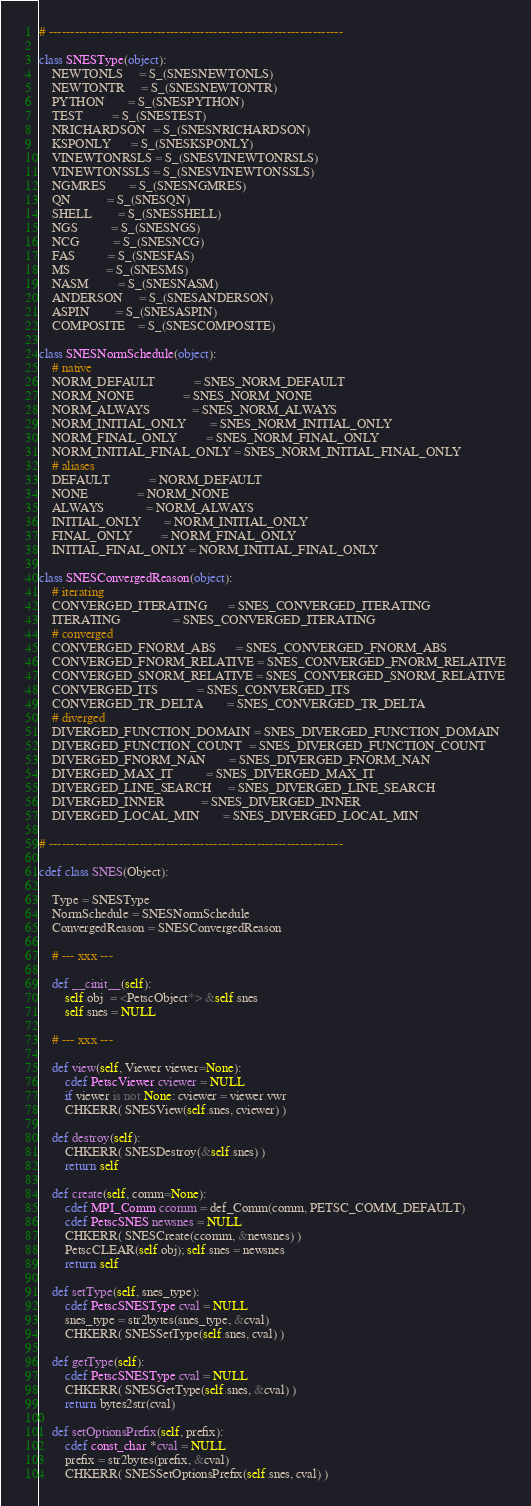Convert code to text. <code><loc_0><loc_0><loc_500><loc_500><_Cython_># --------------------------------------------------------------------

class SNESType(object):
    NEWTONLS     = S_(SNESNEWTONLS)
    NEWTONTR     = S_(SNESNEWTONTR)
    PYTHON       = S_(SNESPYTHON)
    TEST         = S_(SNESTEST)
    NRICHARDSON  = S_(SNESNRICHARDSON)
    KSPONLY      = S_(SNESKSPONLY)
    VINEWTONRSLS = S_(SNESVINEWTONRSLS)
    VINEWTONSSLS = S_(SNESVINEWTONSSLS)
    NGMRES       = S_(SNESNGMRES)
    QN           = S_(SNESQN)
    SHELL        = S_(SNESSHELL)
    NGS          = S_(SNESNGS)
    NCG          = S_(SNESNCG)
    FAS          = S_(SNESFAS)
    MS           = S_(SNESMS)
    NASM         = S_(SNESNASM)
    ANDERSON     = S_(SNESANDERSON)
    ASPIN        = S_(SNESASPIN)
    COMPOSITE    = S_(SNESCOMPOSITE)

class SNESNormSchedule(object):
    # native
    NORM_DEFAULT            = SNES_NORM_DEFAULT
    NORM_NONE               = SNES_NORM_NONE
    NORM_ALWAYS             = SNES_NORM_ALWAYS
    NORM_INITIAL_ONLY       = SNES_NORM_INITIAL_ONLY
    NORM_FINAL_ONLY         = SNES_NORM_FINAL_ONLY
    NORM_INITIAL_FINAL_ONLY = SNES_NORM_INITIAL_FINAL_ONLY
    # aliases
    DEFAULT            = NORM_DEFAULT
    NONE               = NORM_NONE
    ALWAYS             = NORM_ALWAYS
    INITIAL_ONLY       = NORM_INITIAL_ONLY
    FINAL_ONLY         = NORM_FINAL_ONLY
    INITIAL_FINAL_ONLY = NORM_INITIAL_FINAL_ONLY

class SNESConvergedReason(object):
    # iterating
    CONVERGED_ITERATING      = SNES_CONVERGED_ITERATING
    ITERATING                = SNES_CONVERGED_ITERATING
    # converged
    CONVERGED_FNORM_ABS      = SNES_CONVERGED_FNORM_ABS
    CONVERGED_FNORM_RELATIVE = SNES_CONVERGED_FNORM_RELATIVE
    CONVERGED_SNORM_RELATIVE = SNES_CONVERGED_SNORM_RELATIVE
    CONVERGED_ITS            = SNES_CONVERGED_ITS
    CONVERGED_TR_DELTA       = SNES_CONVERGED_TR_DELTA
    # diverged
    DIVERGED_FUNCTION_DOMAIN = SNES_DIVERGED_FUNCTION_DOMAIN
    DIVERGED_FUNCTION_COUNT  = SNES_DIVERGED_FUNCTION_COUNT
    DIVERGED_FNORM_NAN       = SNES_DIVERGED_FNORM_NAN
    DIVERGED_MAX_IT          = SNES_DIVERGED_MAX_IT
    DIVERGED_LINE_SEARCH     = SNES_DIVERGED_LINE_SEARCH
    DIVERGED_INNER           = SNES_DIVERGED_INNER
    DIVERGED_LOCAL_MIN       = SNES_DIVERGED_LOCAL_MIN

# --------------------------------------------------------------------

cdef class SNES(Object):

    Type = SNESType
    NormSchedule = SNESNormSchedule
    ConvergedReason = SNESConvergedReason

    # --- xxx ---

    def __cinit__(self):
        self.obj  = <PetscObject*> &self.snes
        self.snes = NULL

    # --- xxx ---

    def view(self, Viewer viewer=None):
        cdef PetscViewer cviewer = NULL
        if viewer is not None: cviewer = viewer.vwr
        CHKERR( SNESView(self.snes, cviewer) )

    def destroy(self):
        CHKERR( SNESDestroy(&self.snes) )
        return self

    def create(self, comm=None):
        cdef MPI_Comm ccomm = def_Comm(comm, PETSC_COMM_DEFAULT)
        cdef PetscSNES newsnes = NULL
        CHKERR( SNESCreate(ccomm, &newsnes) )
        PetscCLEAR(self.obj); self.snes = newsnes
        return self

    def setType(self, snes_type):
        cdef PetscSNESType cval = NULL
        snes_type = str2bytes(snes_type, &cval)
        CHKERR( SNESSetType(self.snes, cval) )

    def getType(self):
        cdef PetscSNESType cval = NULL
        CHKERR( SNESGetType(self.snes, &cval) )
        return bytes2str(cval)

    def setOptionsPrefix(self, prefix):
        cdef const_char *cval = NULL
        prefix = str2bytes(prefix, &cval)
        CHKERR( SNESSetOptionsPrefix(self.snes, cval) )
</code> 